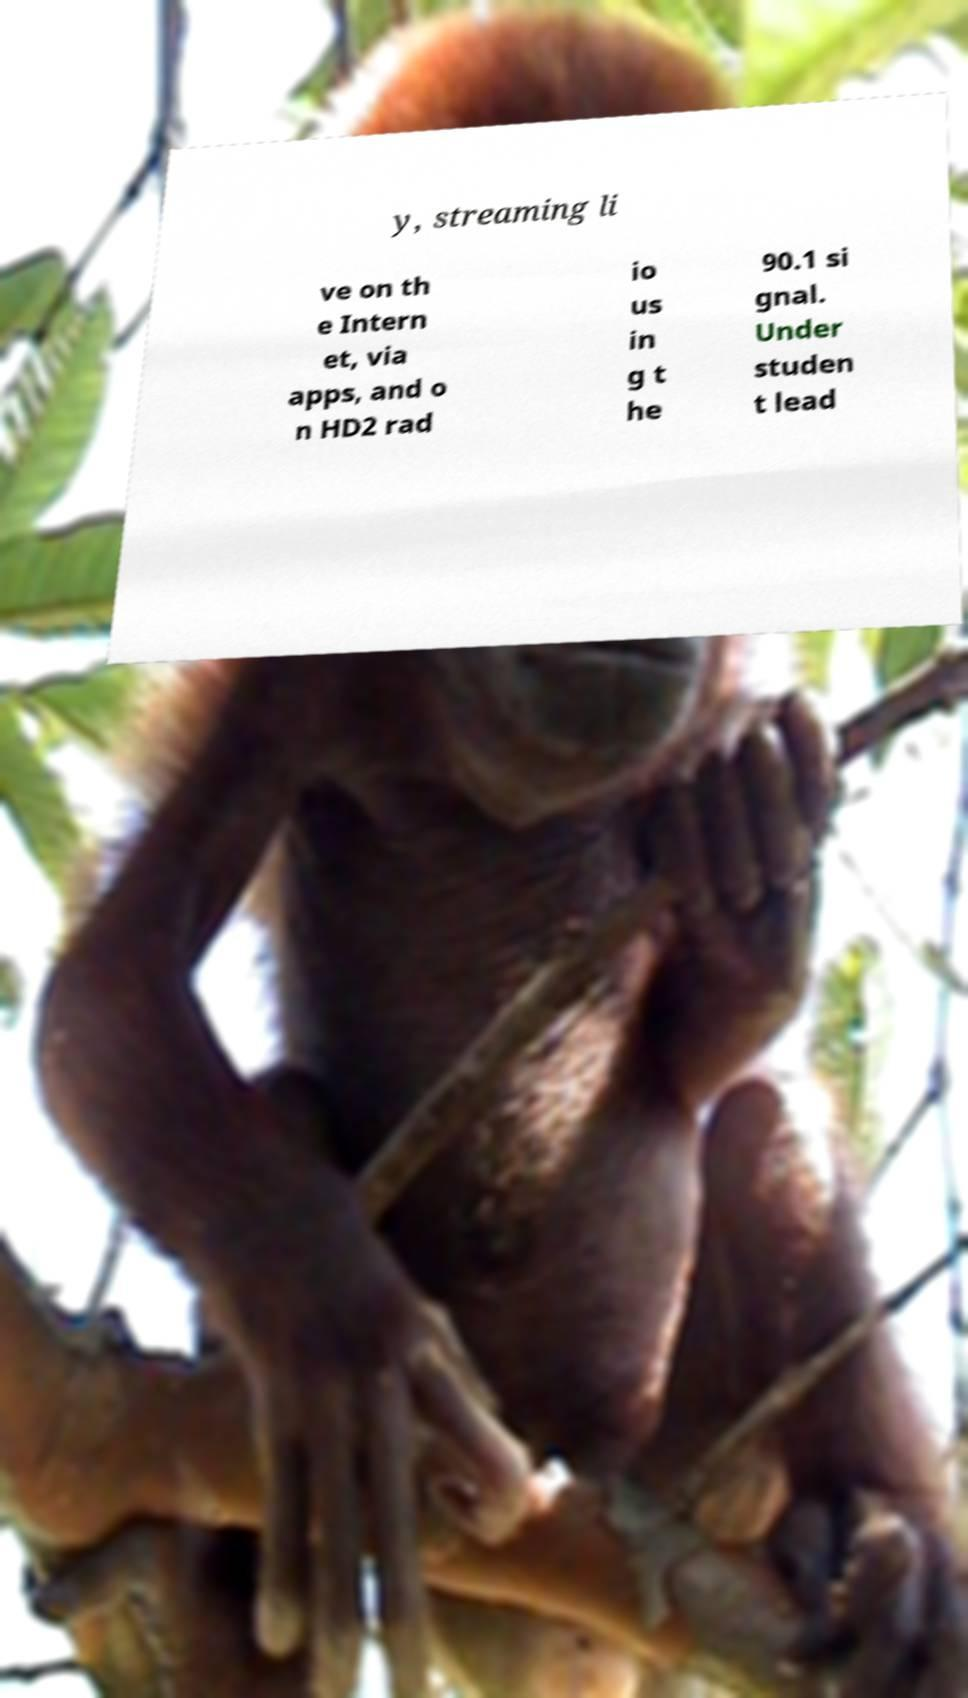Please identify and transcribe the text found in this image. y, streaming li ve on th e Intern et, via apps, and o n HD2 rad io us in g t he 90.1 si gnal. Under studen t lead 